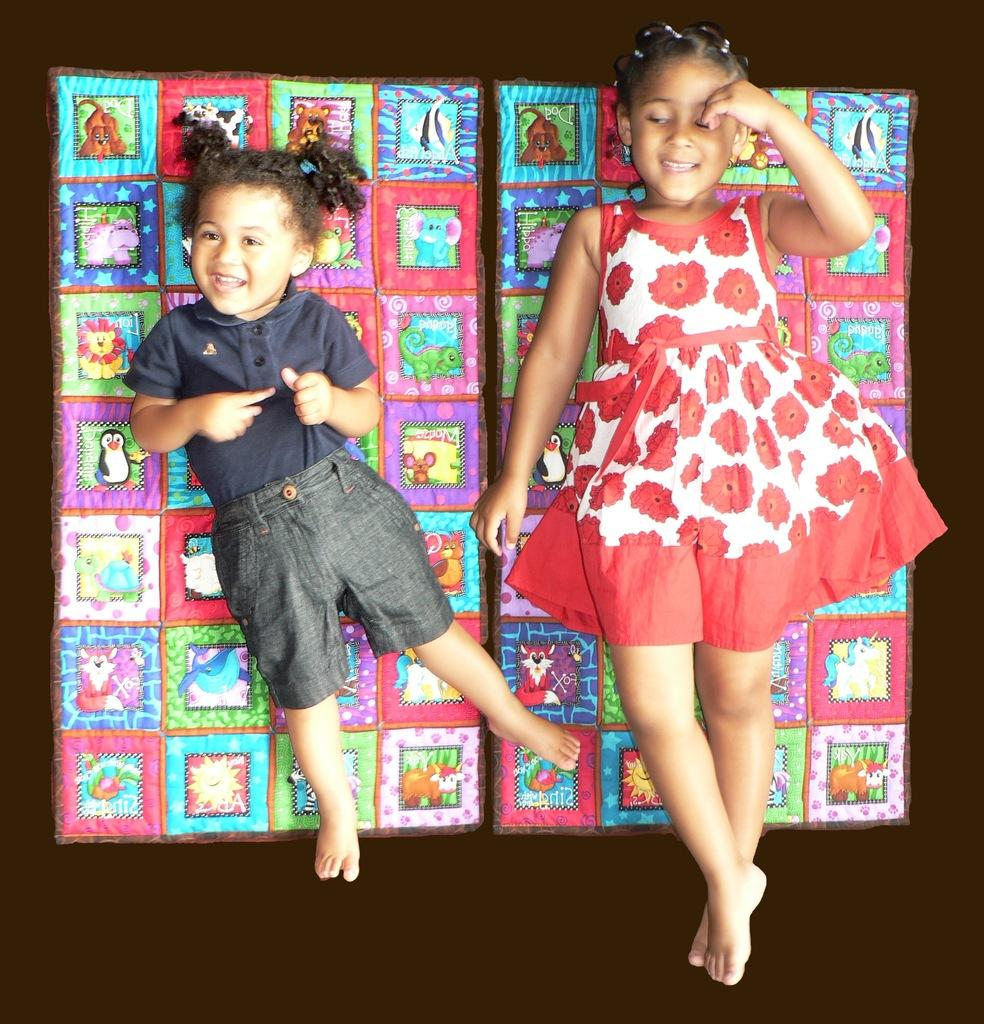How many children are present in the image? There are two children in the image. What are the children doing in the image? The children are lying on mattresses. What is the emotional state of the children in the image? Both children are smiling. What type of bubble can be seen floating near the children in the image? There is no bubble present in the image; the children are lying on mattresses. 